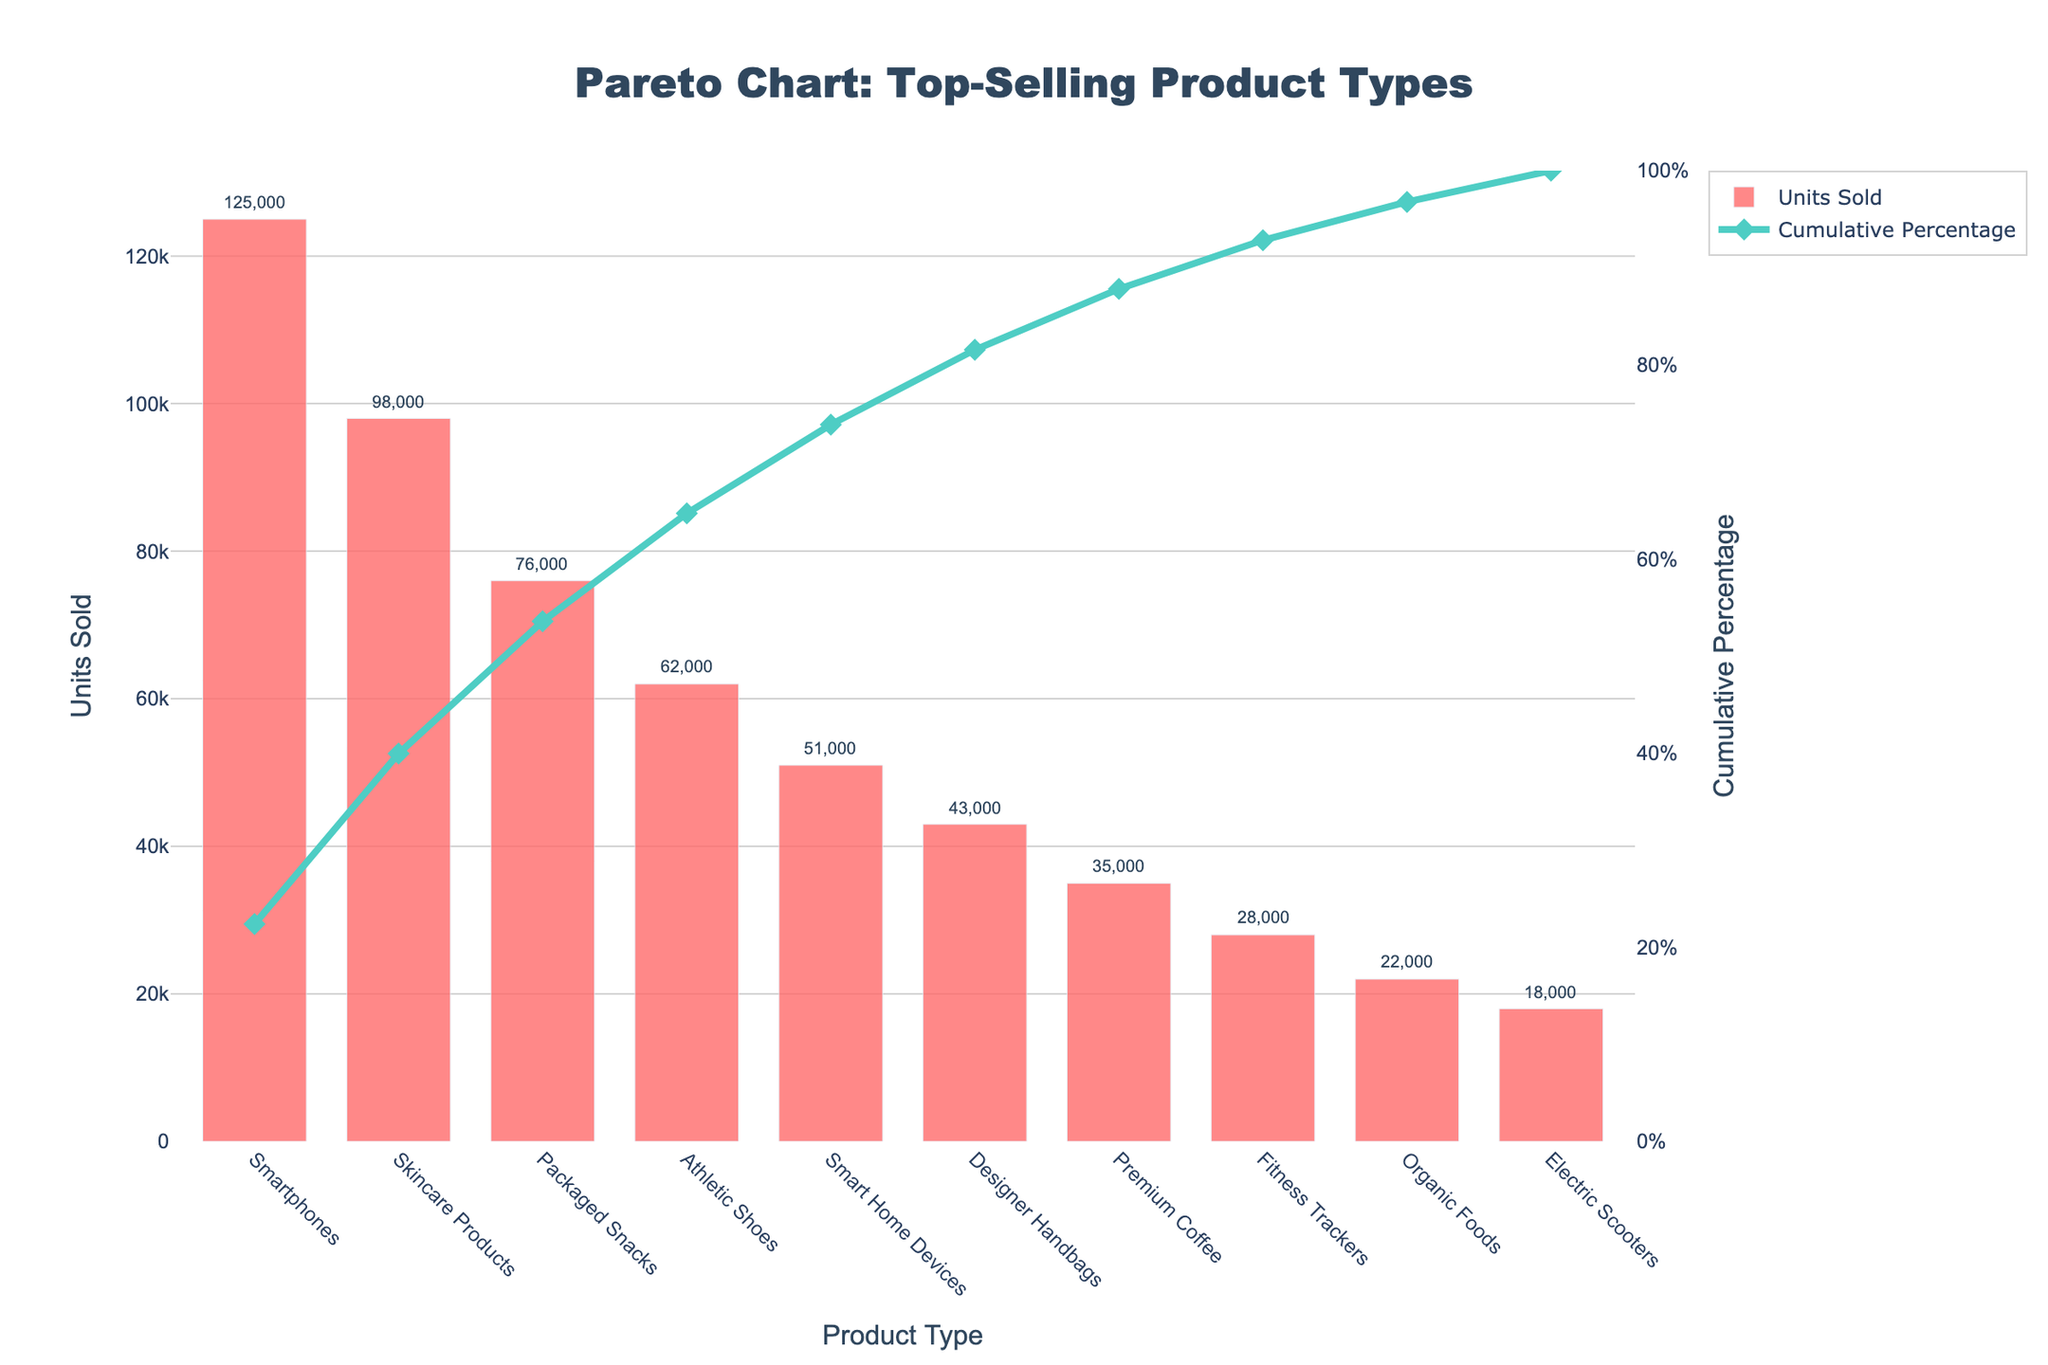Which product type has the highest sales? The top-selling product type is determined by the highest bar in the chart. The "Smartphones" bar is the tallest, indicating it has the highest sales.
Answer: Smartphones What's the title of the chart? The title is usually located at the top of the chart, and it summarizes the entire chart content. Here, it reads "Pareto Chart: Top-Selling Product Types".
Answer: Pareto Chart: Top-Selling Product Types How many product types sold more than 50,000 units? We need to count the bars whose heights exceed the 50,000 units line on the y-axis. The product types are "Smartphones", "Skincare Products", "Packaged Snacks", and "Athletic Shoes".
Answer: 4 Which product types' sales contribute to the cumulative percentage surpassing 80%? To find this, look at the cumulative percentage line and match it to the product types until the percentage exceeds 80%. These include "Smartphones", "Skincare Products", "Packaged Snacks", and "Athletic Shoes".
Answer: Smartphones, Skincare Products, Packaged Snacks, Athletic Shoes What's the cumulative percentage value at "Smart Home Devices"? Locate "Smart Home Devices" on the x-axis and check its cumulative percentage value from the second y-axis on the right. We find it reaches around 80%.
Answer: ~80% By how much do the units sold of "Smartphones" exceed the units sold of "Fitness Trackers"? Find the units sold for both "Smartphones" (125,000 units) and "Fitness Trackers" (28,000 units), then subtract the latter from the former. 125,000 - 28,000 = 97,000 units.
Answer: 97,000 units What is the average units sold for the top three product types? Sum the units sold for the top three types: Smartphones (125,000), Skincare Products (98,000), and Packaged Snacks (76,000). Then divide by 3. (125,000 + 98,000 + 76,000) / 3 = 299,000 / 3 = 99,667 units.
Answer: 99,667 units What's the total number of units sold for all product types combined? Sum the units sold for all product types as displayed on the chart. 125,000 + 98,000 + 76,000 + 62,000 + 51,000 + 43,000 + 35,000 + 28,000 + 22,000 + 18,000 = 558,000.
Answer: 558,000 How does the cumulative percentage line behave between the top two product types? Observe the slope of the line from "Smartphones" to "Skincare Products". It shows a steep increase, indicating a significant contribution to the cumulative percentage by these two products.
Answer: Steep increase Which product type is ranked sixth in terms of units sold? Look at the position of the sixth bar from the left. The sixth bar represents "Designer Handbags", making it the sixth-ranked product type by units sold.
Answer: Designer Handbags 